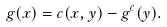Convert formula to latex. <formula><loc_0><loc_0><loc_500><loc_500>g ( x ) = c ( x , y ) - g ^ { c } ( y ) .</formula> 